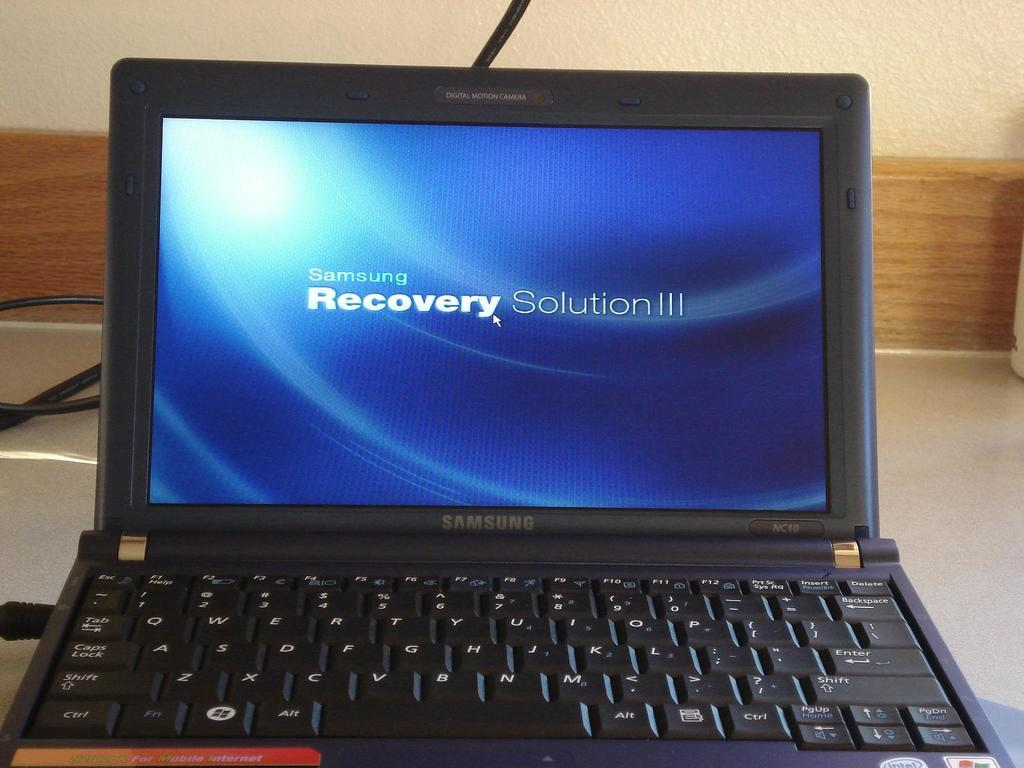<image>
Create a compact narrative representing the image presented. A Samsung computer that has the Recovery Solution III screen pulled up. 